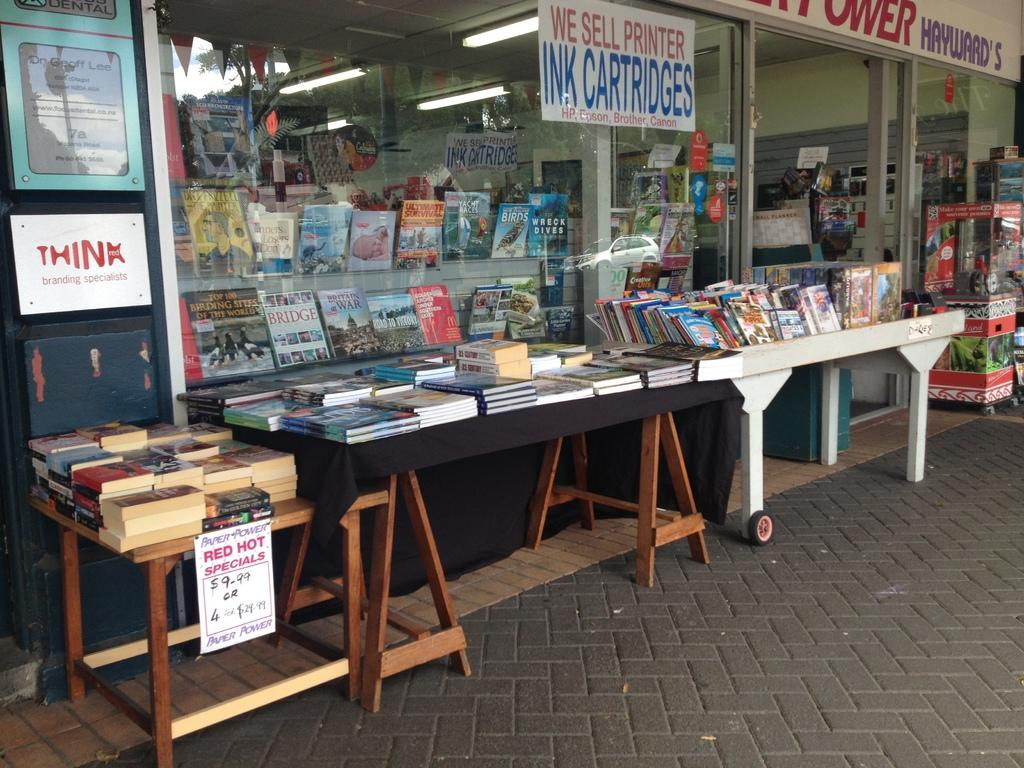What type of furniture is visible in the image? There are tables present in the image. What items are placed on the tables? There are books on the tables. What kind of setting does the image suggest? The scene resembles a shop. What is the color of the moon in the image? There is no moon present in the image. How does the throat of the person in the image look? There is no person present in the image, so we cannot comment on their throat. 